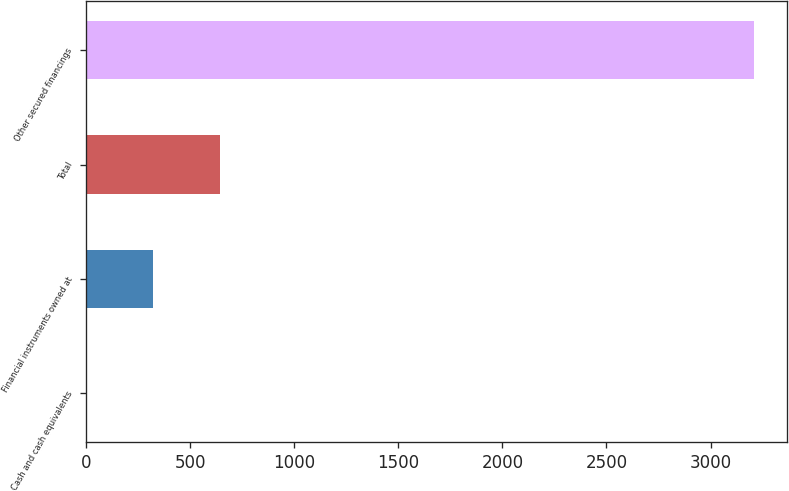<chart> <loc_0><loc_0><loc_500><loc_500><bar_chart><fcel>Cash and cash equivalents<fcel>Financial instruments owned at<fcel>Total<fcel>Other secured financings<nl><fcel>1<fcel>321.7<fcel>642.4<fcel>3208<nl></chart> 